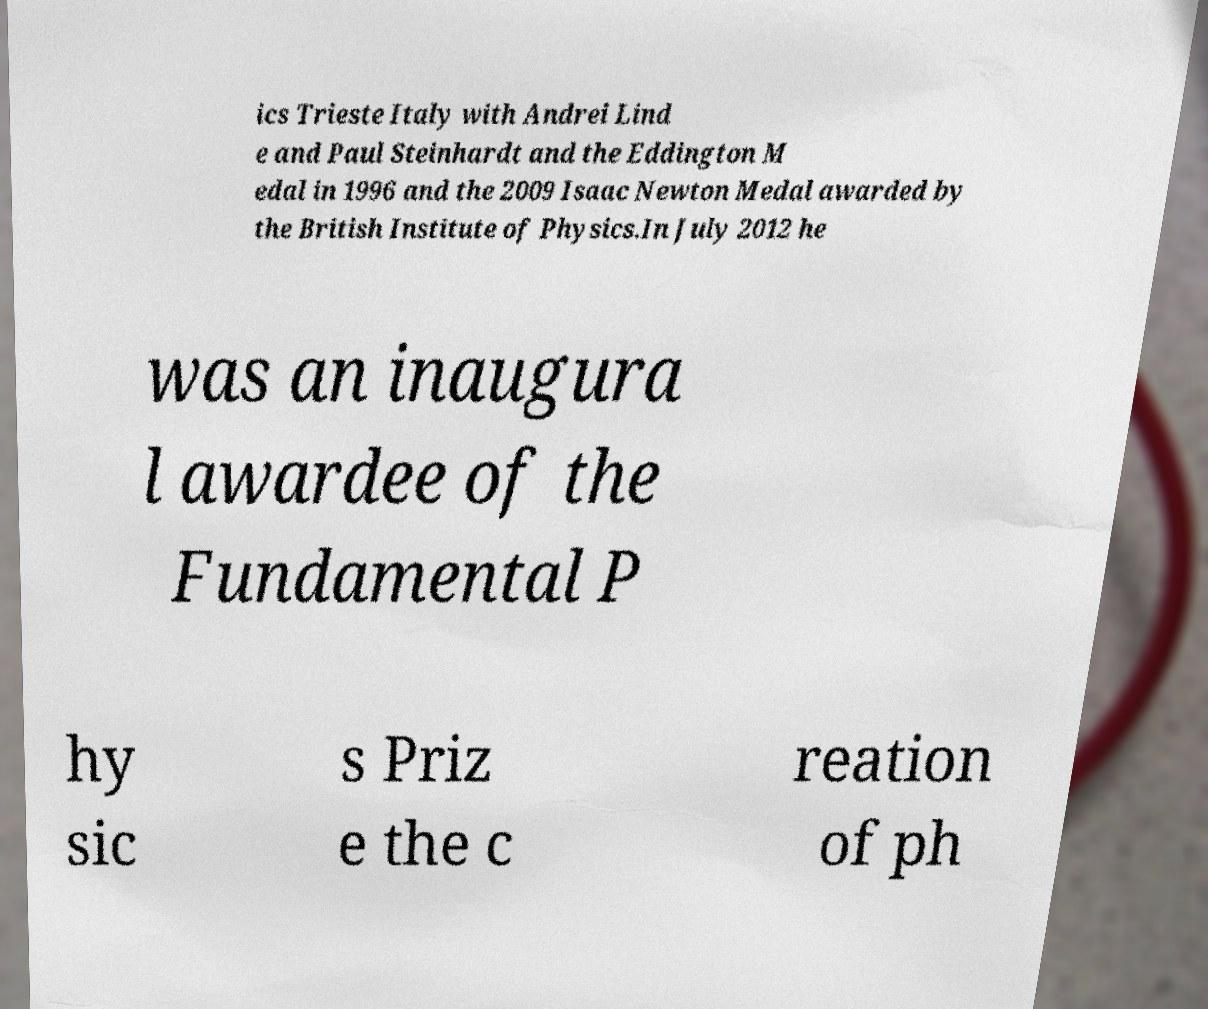Could you extract and type out the text from this image? ics Trieste Italy with Andrei Lind e and Paul Steinhardt and the Eddington M edal in 1996 and the 2009 Isaac Newton Medal awarded by the British Institute of Physics.In July 2012 he was an inaugura l awardee of the Fundamental P hy sic s Priz e the c reation of ph 